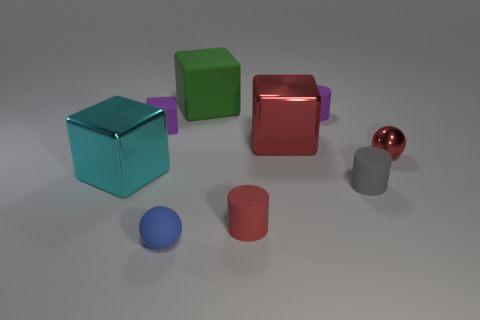There is a tiny cylinder that is behind the large red object; is its color the same as the tiny block?
Make the answer very short. Yes. What is the color of the other rubber object that is the same shape as the big green matte thing?
Offer a very short reply. Purple. What number of tiny objects are either red objects or shiny balls?
Your response must be concise. 2. There is a metal block that is on the right side of the cyan metal cube; what size is it?
Your answer should be compact. Large. Is there a tiny cylinder that has the same color as the shiny ball?
Make the answer very short. Yes. What shape is the tiny matte object that is the same color as the small cube?
Ensure brevity in your answer.  Cylinder. How many large shiny cubes are left of the cylinder in front of the tiny gray rubber object?
Provide a short and direct response. 1. How many large cyan things have the same material as the big green thing?
Provide a succinct answer. 0. Are there any tiny red rubber cylinders to the right of the large green block?
Provide a succinct answer. Yes. What color is the block that is the same size as the purple cylinder?
Ensure brevity in your answer.  Purple. 